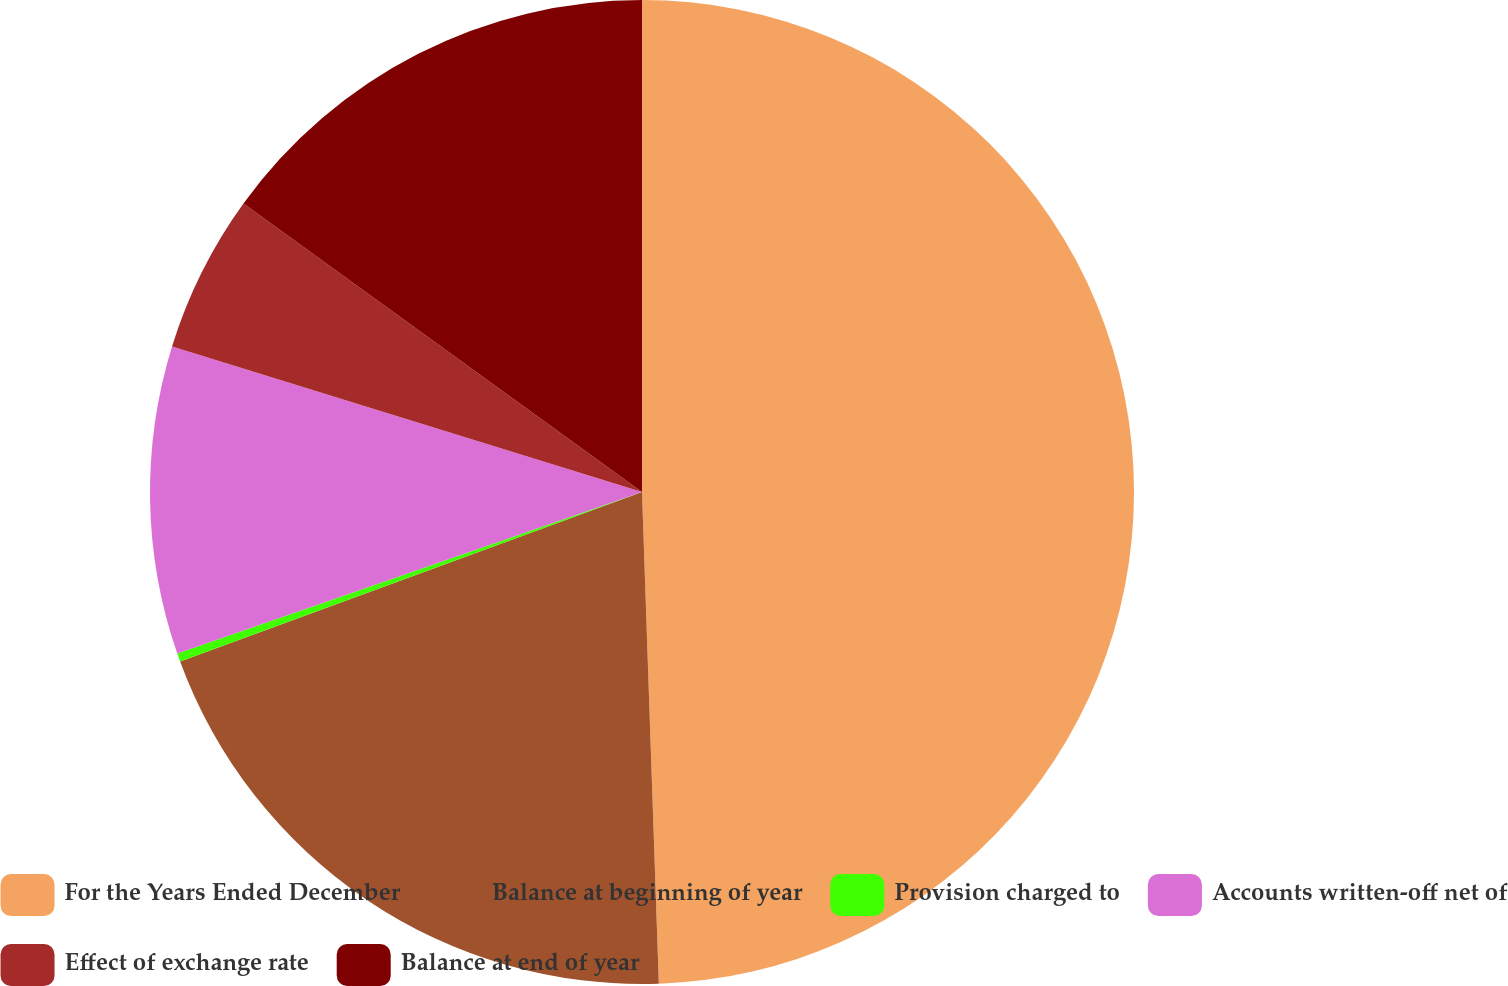Convert chart. <chart><loc_0><loc_0><loc_500><loc_500><pie_chart><fcel>For the Years Ended December<fcel>Balance at beginning of year<fcel>Provision charged to<fcel>Accounts written-off net of<fcel>Effect of exchange rate<fcel>Balance at end of year<nl><fcel>49.46%<fcel>19.95%<fcel>0.27%<fcel>10.11%<fcel>5.19%<fcel>15.03%<nl></chart> 